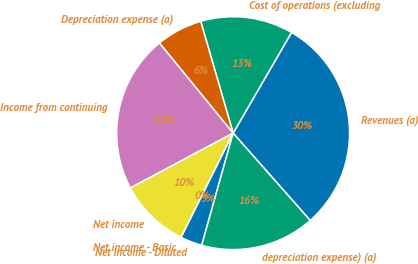Convert chart. <chart><loc_0><loc_0><loc_500><loc_500><pie_chart><fcel>Revenues (a)<fcel>Cost of operations (excluding<fcel>Depreciation expense (a)<fcel>Income from continuing<fcel>Net income<fcel>Net income - Basic<fcel>Net income - Diluted<fcel>depreciation expense) (a)<nl><fcel>30.12%<fcel>12.85%<fcel>6.42%<fcel>21.89%<fcel>9.84%<fcel>0.0%<fcel>3.01%<fcel>15.86%<nl></chart> 